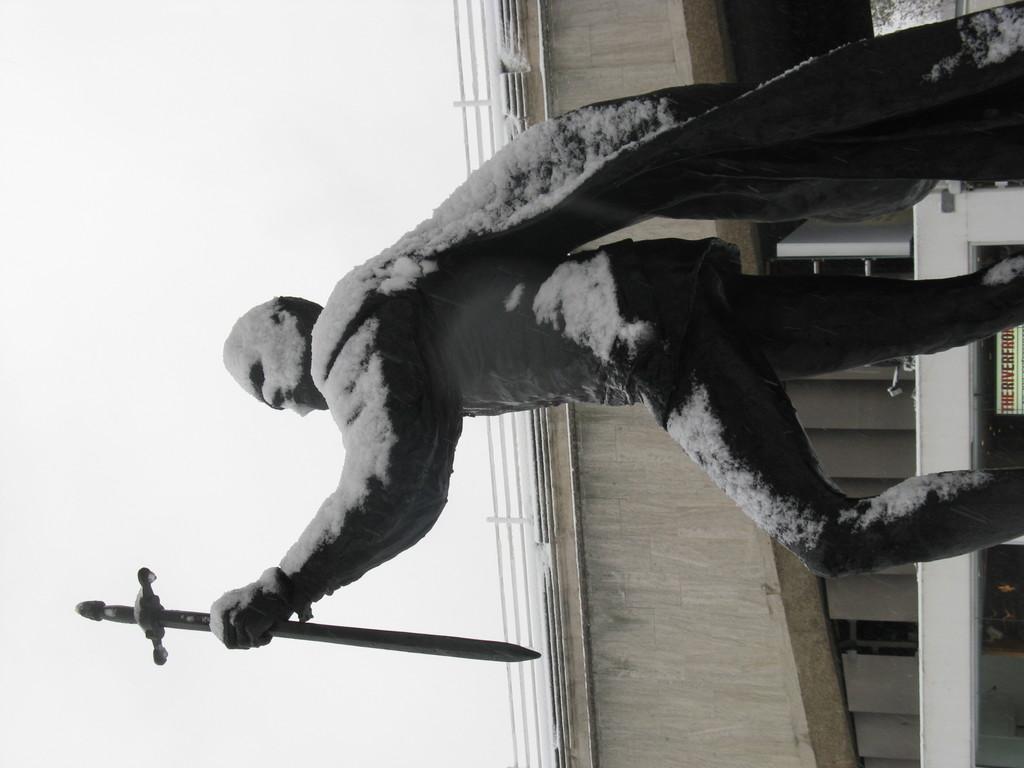How would you summarize this image in a sentence or two? In the picture we can see a sculpture of a man standing and holding a sword and on the sculpture we can see the snow and behind it, we can see a part of the bridge with a railing to it. 